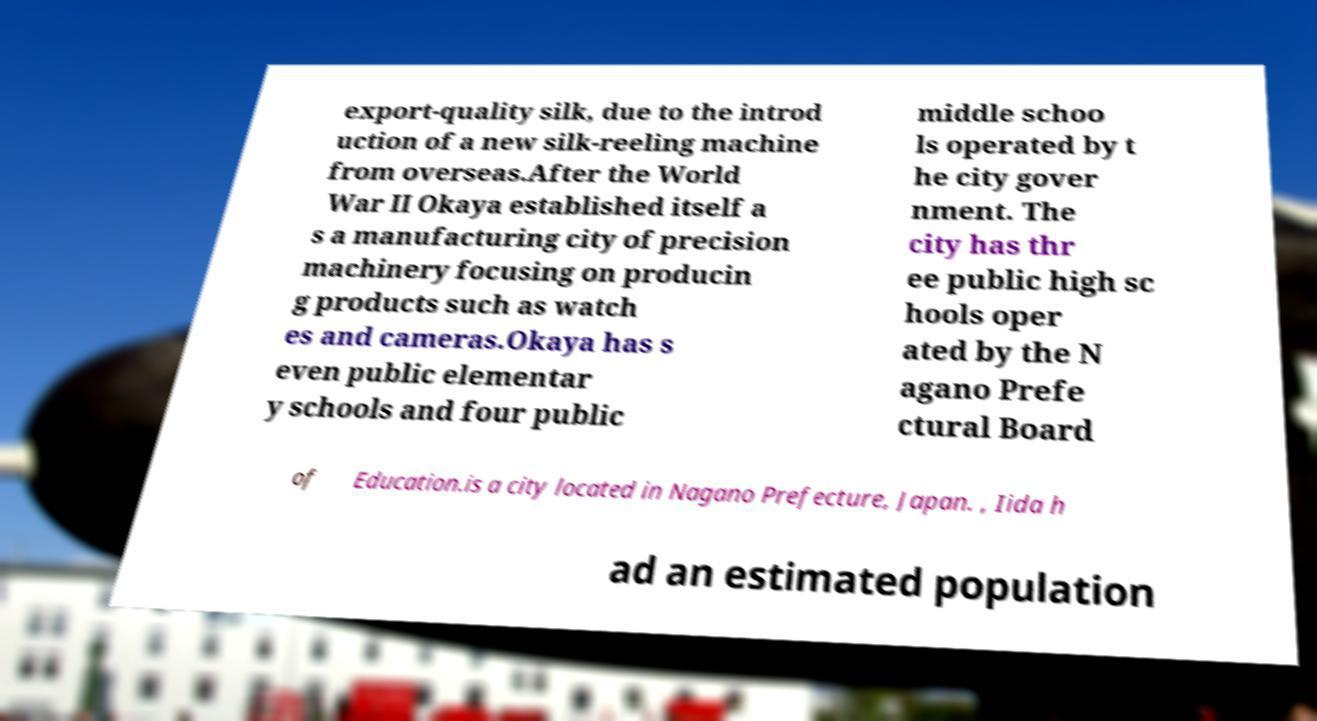What messages or text are displayed in this image? I need them in a readable, typed format. export-quality silk, due to the introd uction of a new silk-reeling machine from overseas.After the World War II Okaya established itself a s a manufacturing city of precision machinery focusing on producin g products such as watch es and cameras.Okaya has s even public elementar y schools and four public middle schoo ls operated by t he city gover nment. The city has thr ee public high sc hools oper ated by the N agano Prefe ctural Board of Education.is a city located in Nagano Prefecture, Japan. , Iida h ad an estimated population 